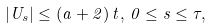<formula> <loc_0><loc_0><loc_500><loc_500>| U _ { s } | \leq ( a + 2 ) \, t , \, 0 \leq s \leq \tau ,</formula> 